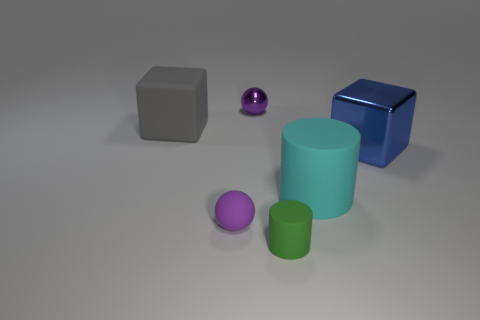Add 4 cyan shiny balls. How many objects exist? 10 Subtract all balls. How many objects are left? 4 Add 5 big blue metal objects. How many big blue metal objects are left? 6 Add 5 purple metal things. How many purple metal things exist? 6 Subtract 0 red cylinders. How many objects are left? 6 Subtract all brown spheres. Subtract all green matte cylinders. How many objects are left? 5 